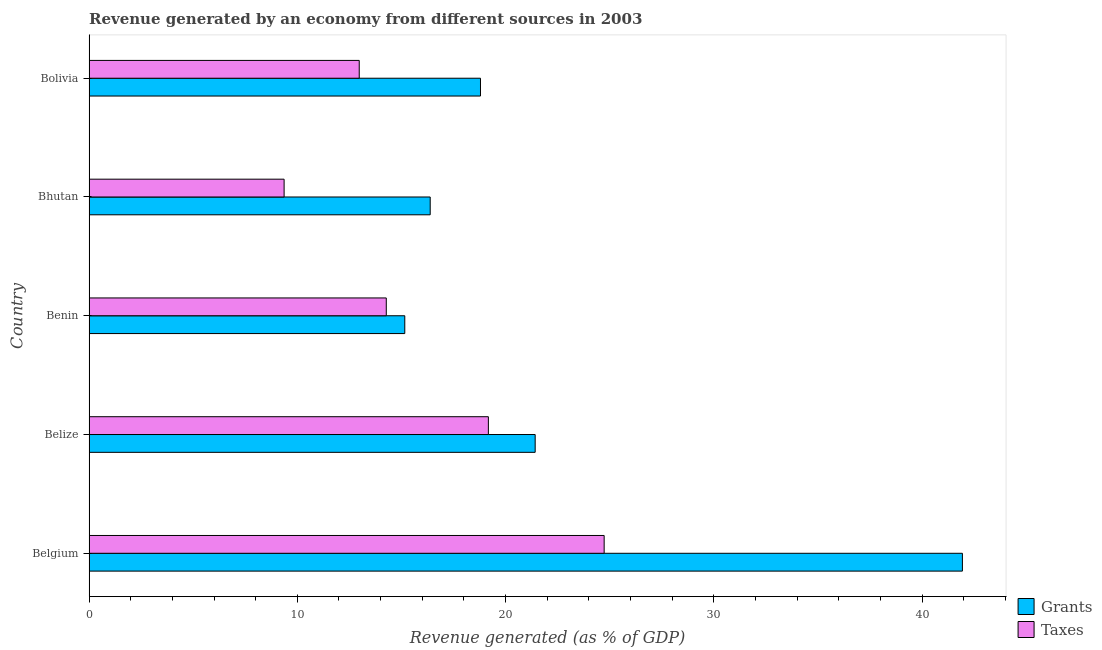How many different coloured bars are there?
Your answer should be very brief. 2. How many bars are there on the 1st tick from the top?
Your response must be concise. 2. How many bars are there on the 2nd tick from the bottom?
Ensure brevity in your answer.  2. In how many cases, is the number of bars for a given country not equal to the number of legend labels?
Ensure brevity in your answer.  0. What is the revenue generated by taxes in Benin?
Your response must be concise. 14.27. Across all countries, what is the maximum revenue generated by grants?
Provide a short and direct response. 41.94. Across all countries, what is the minimum revenue generated by grants?
Make the answer very short. 15.16. In which country was the revenue generated by taxes maximum?
Offer a terse response. Belgium. In which country was the revenue generated by taxes minimum?
Your response must be concise. Bhutan. What is the total revenue generated by grants in the graph?
Offer a terse response. 113.7. What is the difference between the revenue generated by grants in Benin and that in Bolivia?
Make the answer very short. -3.64. What is the difference between the revenue generated by taxes in Bolivia and the revenue generated by grants in Belize?
Offer a terse response. -8.45. What is the average revenue generated by grants per country?
Keep it short and to the point. 22.74. What is the difference between the revenue generated by taxes and revenue generated by grants in Bhutan?
Your response must be concise. -7.02. In how many countries, is the revenue generated by grants greater than 24 %?
Keep it short and to the point. 1. What is the ratio of the revenue generated by taxes in Benin to that in Bhutan?
Make the answer very short. 1.52. What is the difference between the highest and the second highest revenue generated by taxes?
Your response must be concise. 5.56. What is the difference between the highest and the lowest revenue generated by grants?
Give a very brief answer. 26.78. In how many countries, is the revenue generated by grants greater than the average revenue generated by grants taken over all countries?
Give a very brief answer. 1. Is the sum of the revenue generated by grants in Belgium and Bolivia greater than the maximum revenue generated by taxes across all countries?
Offer a terse response. Yes. What does the 2nd bar from the top in Benin represents?
Keep it short and to the point. Grants. What does the 2nd bar from the bottom in Belgium represents?
Offer a very short reply. Taxes. Are all the bars in the graph horizontal?
Make the answer very short. Yes. What is the difference between two consecutive major ticks on the X-axis?
Your answer should be compact. 10. Does the graph contain any zero values?
Keep it short and to the point. No. Does the graph contain grids?
Provide a succinct answer. No. Where does the legend appear in the graph?
Offer a terse response. Bottom right. What is the title of the graph?
Make the answer very short. Revenue generated by an economy from different sources in 2003. Does "Electricity and heat production" appear as one of the legend labels in the graph?
Keep it short and to the point. No. What is the label or title of the X-axis?
Your answer should be very brief. Revenue generated (as % of GDP). What is the Revenue generated (as % of GDP) in Grants in Belgium?
Ensure brevity in your answer.  41.94. What is the Revenue generated (as % of GDP) in Taxes in Belgium?
Offer a very short reply. 24.73. What is the Revenue generated (as % of GDP) in Grants in Belize?
Keep it short and to the point. 21.42. What is the Revenue generated (as % of GDP) of Taxes in Belize?
Provide a short and direct response. 19.17. What is the Revenue generated (as % of GDP) of Grants in Benin?
Ensure brevity in your answer.  15.16. What is the Revenue generated (as % of GDP) in Taxes in Benin?
Keep it short and to the point. 14.27. What is the Revenue generated (as % of GDP) of Grants in Bhutan?
Your answer should be very brief. 16.38. What is the Revenue generated (as % of GDP) of Taxes in Bhutan?
Your response must be concise. 9.37. What is the Revenue generated (as % of GDP) in Grants in Bolivia?
Your response must be concise. 18.8. What is the Revenue generated (as % of GDP) of Taxes in Bolivia?
Your answer should be compact. 12.97. Across all countries, what is the maximum Revenue generated (as % of GDP) of Grants?
Give a very brief answer. 41.94. Across all countries, what is the maximum Revenue generated (as % of GDP) of Taxes?
Keep it short and to the point. 24.73. Across all countries, what is the minimum Revenue generated (as % of GDP) in Grants?
Your answer should be compact. 15.16. Across all countries, what is the minimum Revenue generated (as % of GDP) of Taxes?
Keep it short and to the point. 9.37. What is the total Revenue generated (as % of GDP) of Grants in the graph?
Keep it short and to the point. 113.7. What is the total Revenue generated (as % of GDP) of Taxes in the graph?
Offer a very short reply. 80.52. What is the difference between the Revenue generated (as % of GDP) in Grants in Belgium and that in Belize?
Give a very brief answer. 20.52. What is the difference between the Revenue generated (as % of GDP) of Taxes in Belgium and that in Belize?
Make the answer very short. 5.56. What is the difference between the Revenue generated (as % of GDP) of Grants in Belgium and that in Benin?
Your response must be concise. 26.78. What is the difference between the Revenue generated (as % of GDP) in Taxes in Belgium and that in Benin?
Make the answer very short. 10.46. What is the difference between the Revenue generated (as % of GDP) in Grants in Belgium and that in Bhutan?
Keep it short and to the point. 25.56. What is the difference between the Revenue generated (as % of GDP) of Taxes in Belgium and that in Bhutan?
Make the answer very short. 15.37. What is the difference between the Revenue generated (as % of GDP) in Grants in Belgium and that in Bolivia?
Give a very brief answer. 23.14. What is the difference between the Revenue generated (as % of GDP) of Taxes in Belgium and that in Bolivia?
Provide a short and direct response. 11.76. What is the difference between the Revenue generated (as % of GDP) in Grants in Belize and that in Benin?
Your answer should be compact. 6.26. What is the difference between the Revenue generated (as % of GDP) in Taxes in Belize and that in Benin?
Ensure brevity in your answer.  4.9. What is the difference between the Revenue generated (as % of GDP) in Grants in Belize and that in Bhutan?
Your answer should be very brief. 5.04. What is the difference between the Revenue generated (as % of GDP) of Taxes in Belize and that in Bhutan?
Offer a very short reply. 9.81. What is the difference between the Revenue generated (as % of GDP) in Grants in Belize and that in Bolivia?
Give a very brief answer. 2.63. What is the difference between the Revenue generated (as % of GDP) of Taxes in Belize and that in Bolivia?
Offer a very short reply. 6.2. What is the difference between the Revenue generated (as % of GDP) of Grants in Benin and that in Bhutan?
Your answer should be compact. -1.22. What is the difference between the Revenue generated (as % of GDP) in Taxes in Benin and that in Bhutan?
Keep it short and to the point. 4.91. What is the difference between the Revenue generated (as % of GDP) of Grants in Benin and that in Bolivia?
Provide a short and direct response. -3.64. What is the difference between the Revenue generated (as % of GDP) in Taxes in Benin and that in Bolivia?
Your answer should be compact. 1.3. What is the difference between the Revenue generated (as % of GDP) in Grants in Bhutan and that in Bolivia?
Ensure brevity in your answer.  -2.41. What is the difference between the Revenue generated (as % of GDP) of Taxes in Bhutan and that in Bolivia?
Your answer should be compact. -3.61. What is the difference between the Revenue generated (as % of GDP) in Grants in Belgium and the Revenue generated (as % of GDP) in Taxes in Belize?
Your answer should be compact. 22.76. What is the difference between the Revenue generated (as % of GDP) of Grants in Belgium and the Revenue generated (as % of GDP) of Taxes in Benin?
Give a very brief answer. 27.67. What is the difference between the Revenue generated (as % of GDP) in Grants in Belgium and the Revenue generated (as % of GDP) in Taxes in Bhutan?
Keep it short and to the point. 32.57. What is the difference between the Revenue generated (as % of GDP) of Grants in Belgium and the Revenue generated (as % of GDP) of Taxes in Bolivia?
Offer a terse response. 28.97. What is the difference between the Revenue generated (as % of GDP) of Grants in Belize and the Revenue generated (as % of GDP) of Taxes in Benin?
Your answer should be compact. 7.15. What is the difference between the Revenue generated (as % of GDP) in Grants in Belize and the Revenue generated (as % of GDP) in Taxes in Bhutan?
Keep it short and to the point. 12.06. What is the difference between the Revenue generated (as % of GDP) in Grants in Belize and the Revenue generated (as % of GDP) in Taxes in Bolivia?
Keep it short and to the point. 8.45. What is the difference between the Revenue generated (as % of GDP) of Grants in Benin and the Revenue generated (as % of GDP) of Taxes in Bhutan?
Your response must be concise. 5.79. What is the difference between the Revenue generated (as % of GDP) in Grants in Benin and the Revenue generated (as % of GDP) in Taxes in Bolivia?
Offer a terse response. 2.19. What is the difference between the Revenue generated (as % of GDP) of Grants in Bhutan and the Revenue generated (as % of GDP) of Taxes in Bolivia?
Make the answer very short. 3.41. What is the average Revenue generated (as % of GDP) in Grants per country?
Your answer should be compact. 22.74. What is the average Revenue generated (as % of GDP) in Taxes per country?
Your answer should be very brief. 16.1. What is the difference between the Revenue generated (as % of GDP) in Grants and Revenue generated (as % of GDP) in Taxes in Belgium?
Provide a short and direct response. 17.2. What is the difference between the Revenue generated (as % of GDP) in Grants and Revenue generated (as % of GDP) in Taxes in Belize?
Make the answer very short. 2.25. What is the difference between the Revenue generated (as % of GDP) of Grants and Revenue generated (as % of GDP) of Taxes in Benin?
Offer a very short reply. 0.89. What is the difference between the Revenue generated (as % of GDP) of Grants and Revenue generated (as % of GDP) of Taxes in Bhutan?
Ensure brevity in your answer.  7.02. What is the difference between the Revenue generated (as % of GDP) of Grants and Revenue generated (as % of GDP) of Taxes in Bolivia?
Your answer should be compact. 5.82. What is the ratio of the Revenue generated (as % of GDP) of Grants in Belgium to that in Belize?
Provide a short and direct response. 1.96. What is the ratio of the Revenue generated (as % of GDP) of Taxes in Belgium to that in Belize?
Your answer should be compact. 1.29. What is the ratio of the Revenue generated (as % of GDP) of Grants in Belgium to that in Benin?
Keep it short and to the point. 2.77. What is the ratio of the Revenue generated (as % of GDP) in Taxes in Belgium to that in Benin?
Your response must be concise. 1.73. What is the ratio of the Revenue generated (as % of GDP) of Grants in Belgium to that in Bhutan?
Provide a short and direct response. 2.56. What is the ratio of the Revenue generated (as % of GDP) in Taxes in Belgium to that in Bhutan?
Give a very brief answer. 2.64. What is the ratio of the Revenue generated (as % of GDP) of Grants in Belgium to that in Bolivia?
Offer a terse response. 2.23. What is the ratio of the Revenue generated (as % of GDP) of Taxes in Belgium to that in Bolivia?
Your answer should be compact. 1.91. What is the ratio of the Revenue generated (as % of GDP) of Grants in Belize to that in Benin?
Provide a succinct answer. 1.41. What is the ratio of the Revenue generated (as % of GDP) in Taxes in Belize to that in Benin?
Your answer should be very brief. 1.34. What is the ratio of the Revenue generated (as % of GDP) in Grants in Belize to that in Bhutan?
Your answer should be compact. 1.31. What is the ratio of the Revenue generated (as % of GDP) in Taxes in Belize to that in Bhutan?
Offer a very short reply. 2.05. What is the ratio of the Revenue generated (as % of GDP) of Grants in Belize to that in Bolivia?
Your answer should be compact. 1.14. What is the ratio of the Revenue generated (as % of GDP) of Taxes in Belize to that in Bolivia?
Offer a terse response. 1.48. What is the ratio of the Revenue generated (as % of GDP) in Grants in Benin to that in Bhutan?
Keep it short and to the point. 0.93. What is the ratio of the Revenue generated (as % of GDP) of Taxes in Benin to that in Bhutan?
Offer a terse response. 1.52. What is the ratio of the Revenue generated (as % of GDP) in Grants in Benin to that in Bolivia?
Offer a very short reply. 0.81. What is the ratio of the Revenue generated (as % of GDP) in Taxes in Benin to that in Bolivia?
Offer a very short reply. 1.1. What is the ratio of the Revenue generated (as % of GDP) in Grants in Bhutan to that in Bolivia?
Your answer should be compact. 0.87. What is the ratio of the Revenue generated (as % of GDP) of Taxes in Bhutan to that in Bolivia?
Your answer should be very brief. 0.72. What is the difference between the highest and the second highest Revenue generated (as % of GDP) in Grants?
Keep it short and to the point. 20.52. What is the difference between the highest and the second highest Revenue generated (as % of GDP) in Taxes?
Offer a very short reply. 5.56. What is the difference between the highest and the lowest Revenue generated (as % of GDP) of Grants?
Your response must be concise. 26.78. What is the difference between the highest and the lowest Revenue generated (as % of GDP) in Taxes?
Make the answer very short. 15.37. 